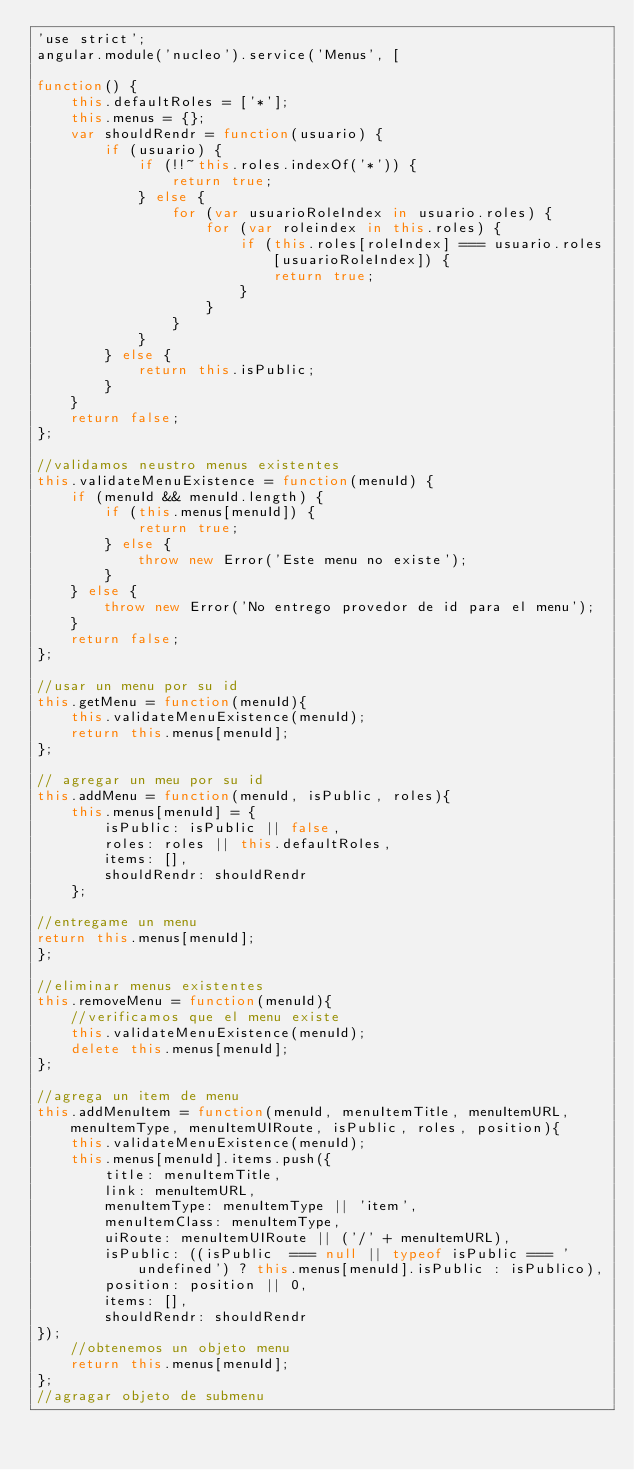<code> <loc_0><loc_0><loc_500><loc_500><_JavaScript_>'use strict';
angular.module('nucleo').service('Menus', [ 

function() {
	this.defaultRoles = ['*'];
	this.menus = {};
	var shouldRendr = function(usuario) {
		if (usuario) {
			if (!!~this.roles.indexOf('*')) {
				return true;
			} else {
				for (var usuarioRoleIndex in usuario.roles) {
					for (var roleindex in this.roles) {
						if (this.roles[roleIndex] === usuario.roles[usuarioRoleIndex]) {
							return true;
						}
					}
				}
			}
		} else {
			return this.isPublic;
		}
	}
	return false;
};

//validamos neustro menus existentes
this.validateMenuExistence = function(menuId) {
	if (menuId && menuId.length) {
		if (this.menus[menuId]) {
			return true;
		} else {
			throw new Error('Este menu no existe');
		}
	} else {
		throw new Error('No entrego provedor de id para el menu');
	}
	return false;
};

//usar un menu por su id
this.getMenu = function(menuId){
	this.validateMenuExistence(menuId);
	return this.menus[menuId];
};

// agregar un meu por su id
this.addMenu = function(menuId, isPublic, roles){
	this.menus[menuId] = {
		isPublic: isPublic || false,
		roles: roles || this.defaultRoles,
		items: [],
		shouldRendr: shouldRendr
	};

//entregame un menu
return this.menus[menuId];
};

//eliminar menus existentes
this.removeMenu = function(menuId){
	//verificamos que el menu existe
	this.validateMenuExistence(menuId);
	delete this.menus[menuId];
};

//agrega un item de menu
this.addMenuItem = function(menuId, menuItemTitle, menuItemURL, menuItemType, menuItemUIRoute, isPublic, roles, position){
	this.validateMenuExistence(menuId);
	this.menus[menuId].items.push({
		title: menuItemTitle,
		link: menuItemURL,
		menuItemType: menuItemType || 'item',
		menuItemClass: menuItemType,
		uiRoute: menuItemUIRoute || ('/' + menuItemURL),
		isPublic: ((isPublic  === null || typeof isPublic === 'undefined') ? this.menus[menuId].isPublic : isPublico),
		position: position || 0,
		items: [],
		shouldRendr: shouldRendr
});
	//obtenemos un objeto menu
	return this.menus[menuId];
};
//agragar objeto de submenu</code> 